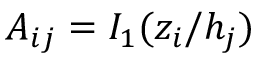Convert formula to latex. <formula><loc_0><loc_0><loc_500><loc_500>A _ { i j } = I _ { 1 } ( z _ { i } / h _ { j } )</formula> 